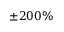<formula> <loc_0><loc_0><loc_500><loc_500>\pm 2 0 0 \%</formula> 